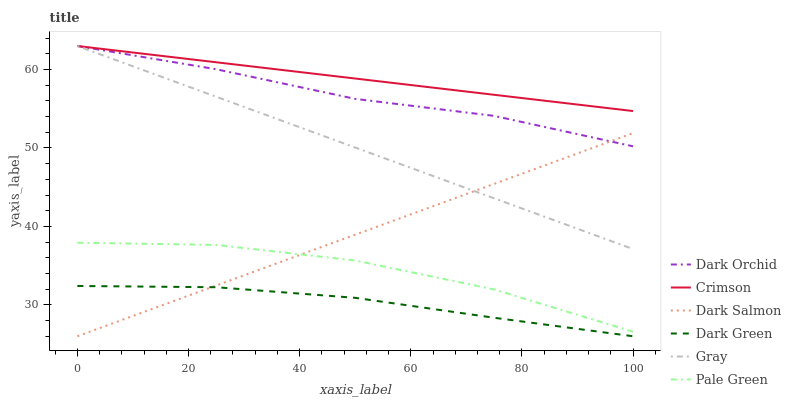Does Dark Green have the minimum area under the curve?
Answer yes or no. Yes. Does Crimson have the maximum area under the curve?
Answer yes or no. Yes. Does Dark Salmon have the minimum area under the curve?
Answer yes or no. No. Does Dark Salmon have the maximum area under the curve?
Answer yes or no. No. Is Dark Salmon the smoothest?
Answer yes or no. Yes. Is Pale Green the roughest?
Answer yes or no. Yes. Is Dark Orchid the smoothest?
Answer yes or no. No. Is Dark Orchid the roughest?
Answer yes or no. No. Does Dark Orchid have the lowest value?
Answer yes or no. No. Does Crimson have the highest value?
Answer yes or no. Yes. Does Dark Salmon have the highest value?
Answer yes or no. No. Is Dark Salmon less than Crimson?
Answer yes or no. Yes. Is Crimson greater than Pale Green?
Answer yes or no. Yes. Does Crimson intersect Dark Orchid?
Answer yes or no. Yes. Is Crimson less than Dark Orchid?
Answer yes or no. No. Is Crimson greater than Dark Orchid?
Answer yes or no. No. Does Dark Salmon intersect Crimson?
Answer yes or no. No. 